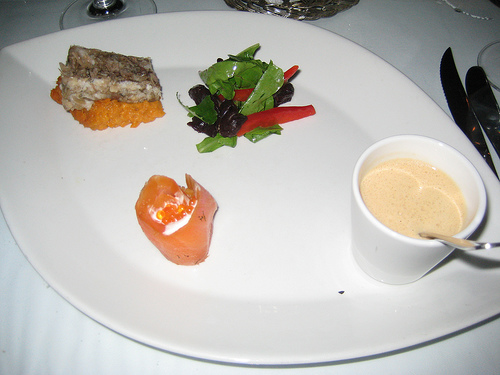<image>
Is there a drink above the plate? Yes. The drink is positioned above the plate in the vertical space, higher up in the scene. 